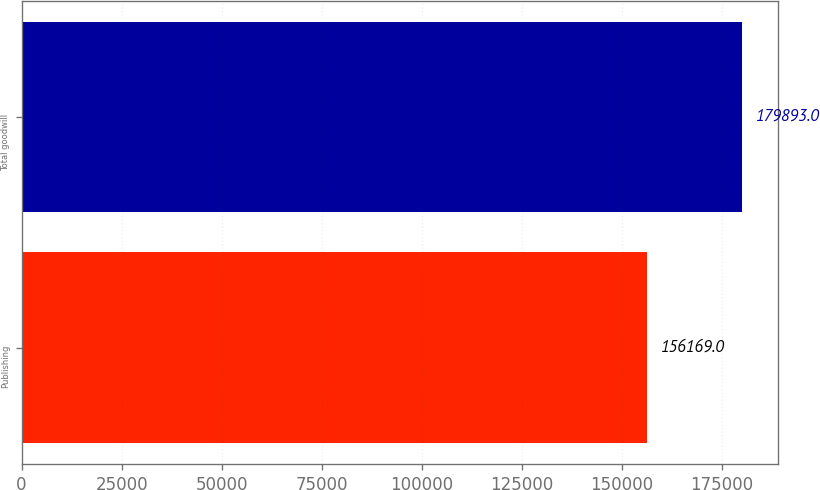Convert chart. <chart><loc_0><loc_0><loc_500><loc_500><bar_chart><fcel>Publishing<fcel>Total goodwill<nl><fcel>156169<fcel>179893<nl></chart> 